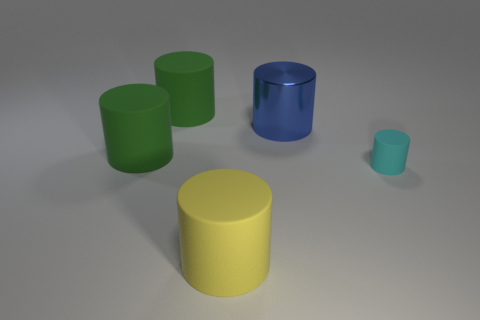Subtract all yellow balls. How many green cylinders are left? 2 Subtract all green cylinders. How many cylinders are left? 3 Subtract all cyan cylinders. How many cylinders are left? 4 Add 3 objects. How many objects exist? 8 Subtract all cyan cylinders. Subtract all brown balls. How many cylinders are left? 4 Subtract all large brown cylinders. Subtract all big rubber cylinders. How many objects are left? 2 Add 2 large blue metallic things. How many large blue metallic things are left? 3 Add 2 small rubber cylinders. How many small rubber cylinders exist? 3 Subtract 1 yellow cylinders. How many objects are left? 4 